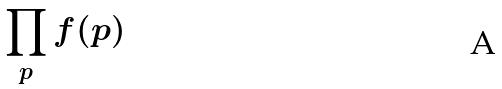<formula> <loc_0><loc_0><loc_500><loc_500>\prod _ { p } f ( p )</formula> 